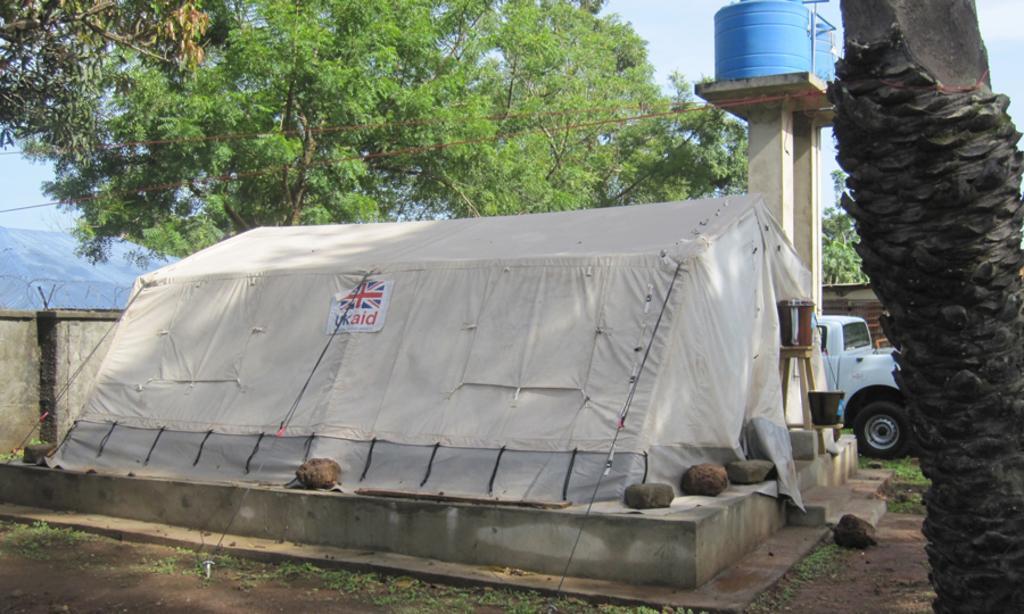Could you give a brief overview of what you see in this image? In this image I can see the ground, some grass on the ground, a tree, a tent which is cream in color, a vehicle which is white in color and a water tank which is blue in color. In the background I can see few trees and the sky. 